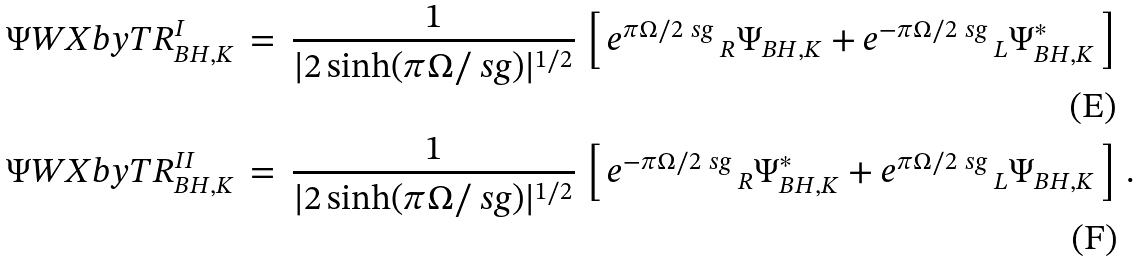Convert formula to latex. <formula><loc_0><loc_0><loc_500><loc_500>\Psi W X b y T R _ { B H , K } ^ { I } \, & = \, \frac { 1 } { | 2 \sinh ( \pi \Omega / \ s g ) | ^ { 1 / 2 } } \, \left [ \, e ^ { \pi \Omega / 2 \ s g } \, _ { R } \Psi _ { B H , K } + e ^ { - \pi \Omega / 2 \ s g } \, _ { L } \Psi _ { B H , K } ^ { \ast } \, \right ] \\ \Psi W X b y T R _ { B H , K } ^ { I I } \, & = \, \frac { 1 } { | 2 \sinh ( \pi \Omega / \ s g ) | ^ { 1 / 2 } } \, \left [ \, e ^ { - \pi \Omega / 2 \ s g } \, _ { R } \Psi _ { B H , K } ^ { \ast } + e ^ { \pi \Omega / 2 \ s g } \, _ { L } \Psi _ { B H , K } \, \right ] \, .</formula> 